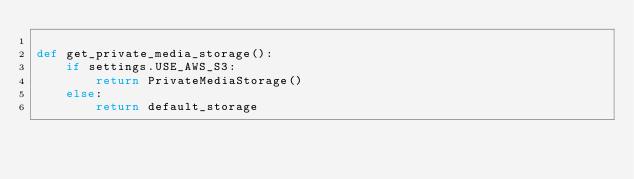Convert code to text. <code><loc_0><loc_0><loc_500><loc_500><_Python_>
def get_private_media_storage():
    if settings.USE_AWS_S3:
        return PrivateMediaStorage()
    else:
        return default_storage
</code> 